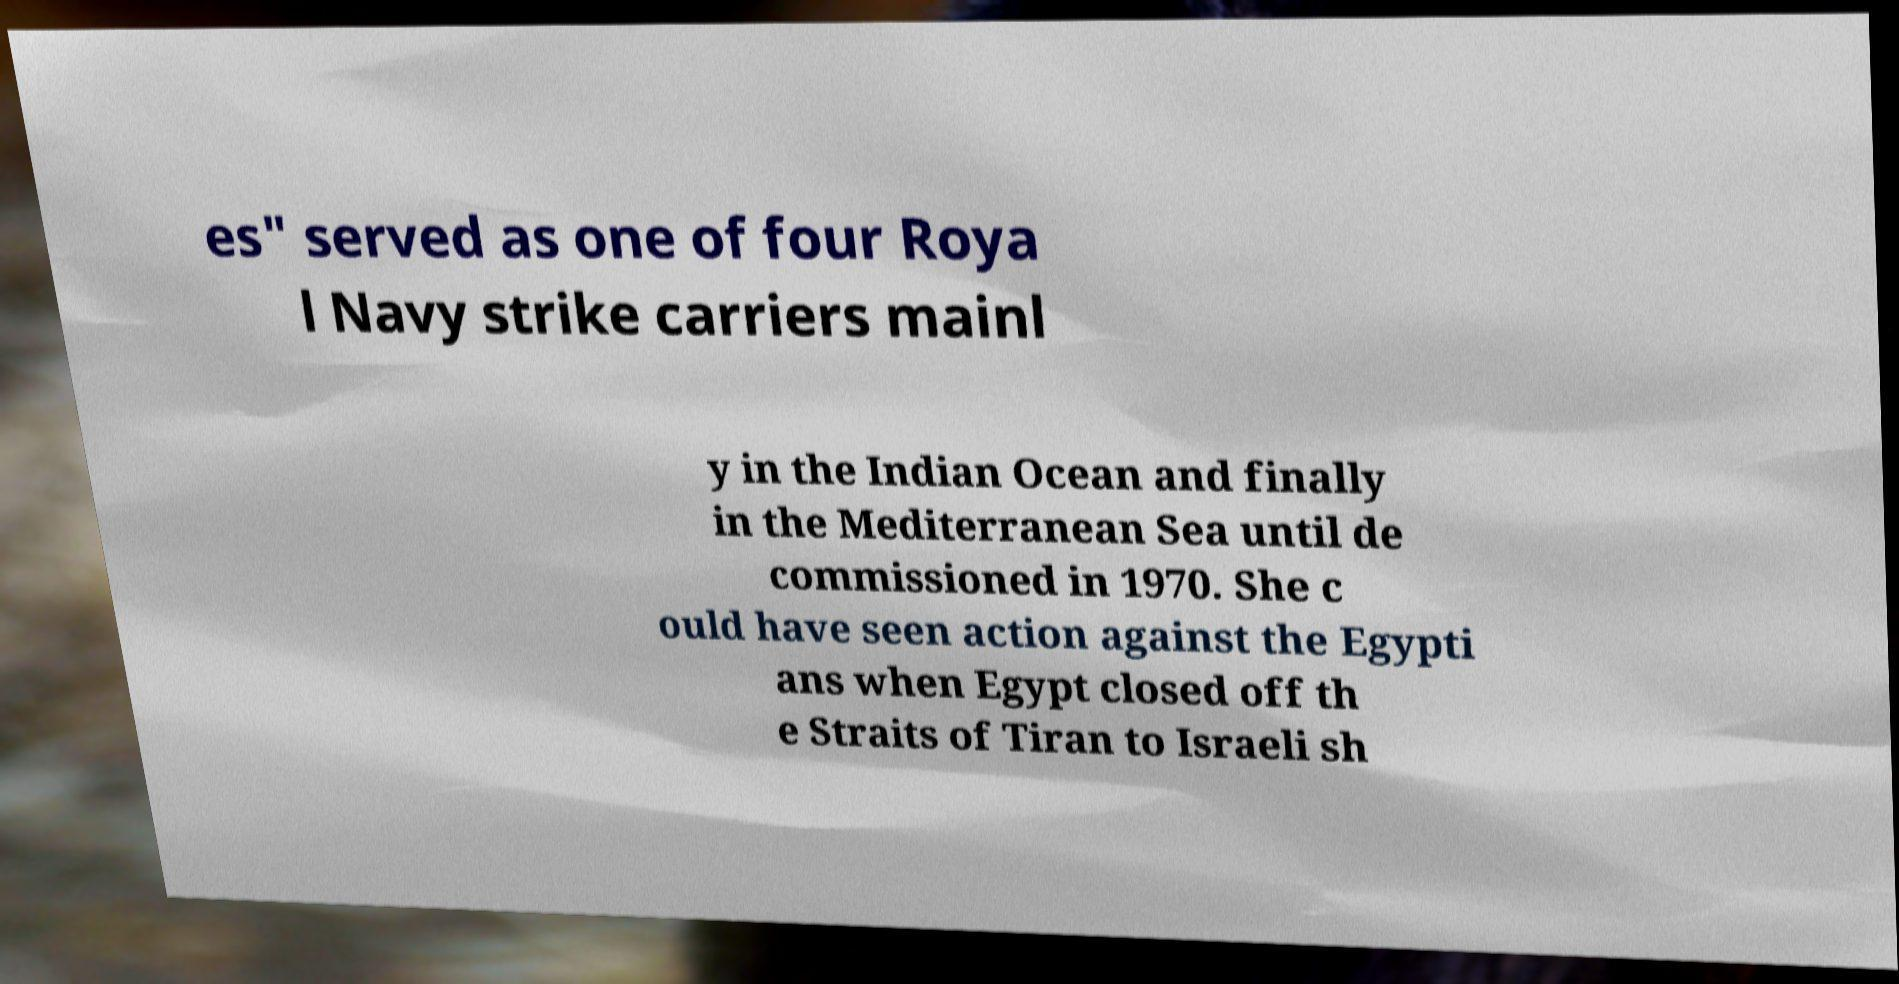For documentation purposes, I need the text within this image transcribed. Could you provide that? es" served as one of four Roya l Navy strike carriers mainl y in the Indian Ocean and finally in the Mediterranean Sea until de commissioned in 1970. She c ould have seen action against the Egypti ans when Egypt closed off th e Straits of Tiran to Israeli sh 